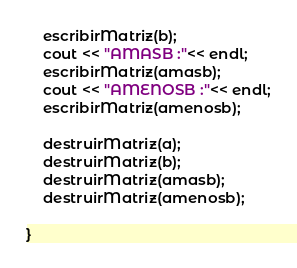Convert code to text. <code><loc_0><loc_0><loc_500><loc_500><_C++_>	escribirMatriz(b);
	cout << "AMASB :"<< endl;
	escribirMatriz(amasb);
	cout << "AMENOSB :"<< endl;
	escribirMatriz(amenosb);

	destruirMatriz(a);
	destruirMatriz(b);
	destruirMatriz(amasb);
	destruirMatriz(amenosb);
	
}











</code> 